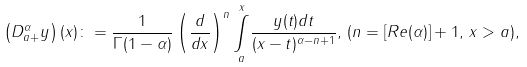Convert formula to latex. <formula><loc_0><loc_0><loc_500><loc_500>\left ( D _ { a + } ^ { \alpha } y \right ) ( x ) \colon = \frac { 1 } { \Gamma ( 1 - \alpha ) } \left ( \frac { d } { d x } \right ) ^ { n } \underset { a } { \overset { x } { \int } } \frac { y ( t ) d t } { ( x - t ) ^ { \alpha - n + 1 } } , \, ( n = \left [ R e ( \alpha ) \right ] + 1 , \, x > a ) ,</formula> 